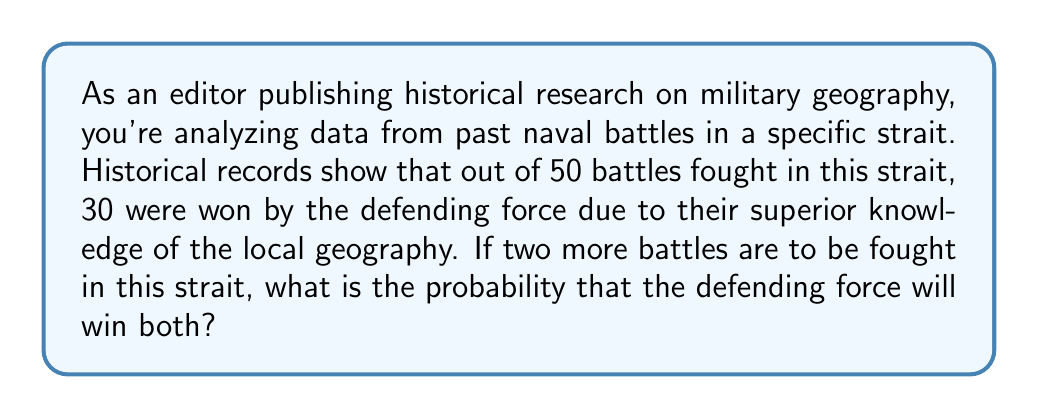Teach me how to tackle this problem. Let's approach this step-by-step:

1) First, we need to calculate the probability of the defending force winning a single battle. 
   This can be done by dividing the number of victories by the total number of battles:

   $P(\text{defender wins}) = \frac{30}{50} = 0.6$ or $60\%$

2) Now, we need to calculate the probability of the defender winning two battles in a row. 
   Since the outcomes of the battles are independent (one battle doesn't affect the other), 
   we can use the multiplication rule of probability:

   $P(\text{defender wins both}) = P(\text{defender wins}) \times P(\text{defender wins})$

3) Substituting our probability from step 1:

   $P(\text{defender wins both}) = 0.6 \times 0.6 = 0.36$

4) To convert to a percentage:

   $0.36 \times 100\% = 36\%$

Therefore, based on the historical data, there is a 36% chance that the defending force will win both of the next two battles in this strait.
Answer: $0.36$ or $36\%$ 